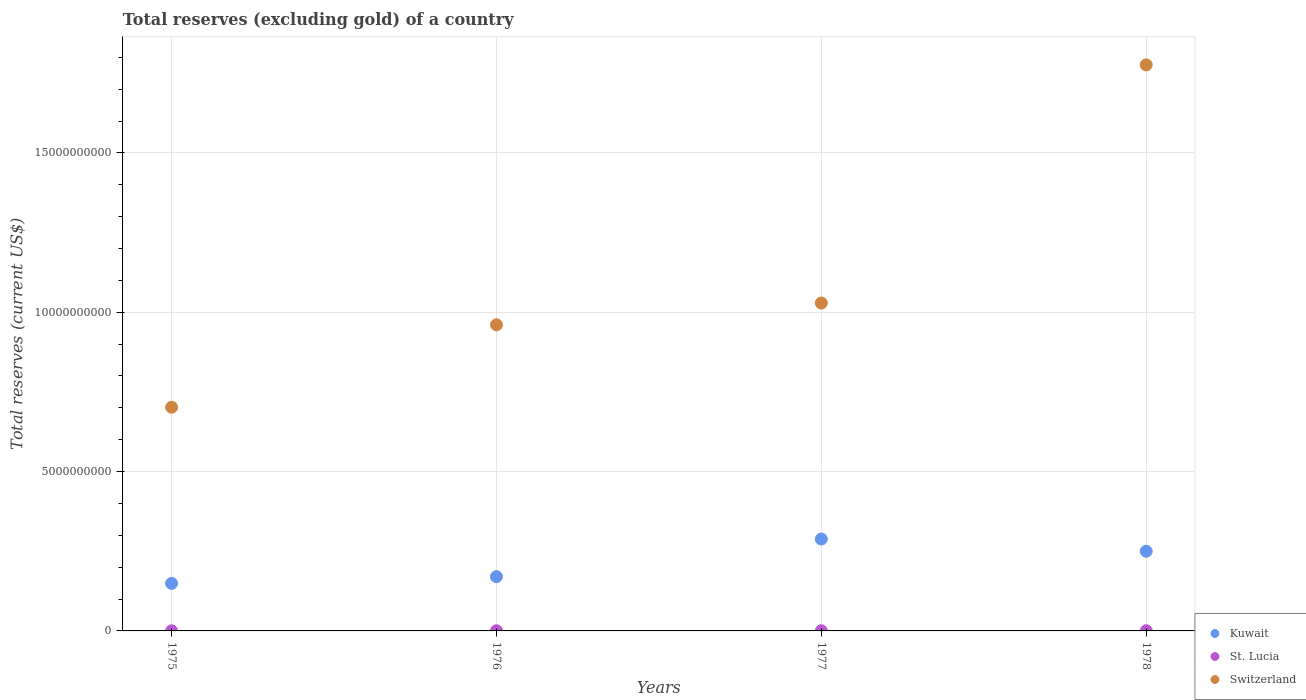Is the number of dotlines equal to the number of legend labels?
Ensure brevity in your answer.  Yes. What is the total reserves (excluding gold) in Switzerland in 1977?
Offer a terse response. 1.03e+1. Across all years, what is the maximum total reserves (excluding gold) in St. Lucia?
Your response must be concise. 6.76e+06. Across all years, what is the minimum total reserves (excluding gold) in Switzerland?
Give a very brief answer. 7.02e+09. In which year was the total reserves (excluding gold) in St. Lucia maximum?
Provide a succinct answer. 1978. In which year was the total reserves (excluding gold) in Switzerland minimum?
Your response must be concise. 1975. What is the total total reserves (excluding gold) in Switzerland in the graph?
Your answer should be compact. 4.47e+1. What is the difference between the total reserves (excluding gold) in Switzerland in 1976 and that in 1978?
Your answer should be compact. -8.16e+09. What is the difference between the total reserves (excluding gold) in St. Lucia in 1978 and the total reserves (excluding gold) in Kuwait in 1977?
Offer a terse response. -2.88e+09. What is the average total reserves (excluding gold) in St. Lucia per year?
Your answer should be very brief. 5.21e+06. In the year 1975, what is the difference between the total reserves (excluding gold) in St. Lucia and total reserves (excluding gold) in Kuwait?
Offer a terse response. -1.49e+09. What is the ratio of the total reserves (excluding gold) in St. Lucia in 1975 to that in 1976?
Provide a short and direct response. 0.62. Is the total reserves (excluding gold) in Kuwait in 1975 less than that in 1976?
Ensure brevity in your answer.  Yes. What is the difference between the highest and the second highest total reserves (excluding gold) in Switzerland?
Give a very brief answer. 7.47e+09. What is the difference between the highest and the lowest total reserves (excluding gold) in Kuwait?
Ensure brevity in your answer.  1.39e+09. Is the sum of the total reserves (excluding gold) in St. Lucia in 1976 and 1977 greater than the maximum total reserves (excluding gold) in Kuwait across all years?
Provide a succinct answer. No. Does the total reserves (excluding gold) in St. Lucia monotonically increase over the years?
Your answer should be compact. Yes. Is the total reserves (excluding gold) in St. Lucia strictly greater than the total reserves (excluding gold) in Kuwait over the years?
Ensure brevity in your answer.  No. Is the total reserves (excluding gold) in Kuwait strictly less than the total reserves (excluding gold) in St. Lucia over the years?
Keep it short and to the point. No. Does the graph contain any zero values?
Your answer should be compact. No. Does the graph contain grids?
Make the answer very short. Yes. Where does the legend appear in the graph?
Your answer should be very brief. Bottom right. How many legend labels are there?
Your answer should be compact. 3. How are the legend labels stacked?
Ensure brevity in your answer.  Vertical. What is the title of the graph?
Ensure brevity in your answer.  Total reserves (excluding gold) of a country. Does "Hong Kong" appear as one of the legend labels in the graph?
Ensure brevity in your answer.  No. What is the label or title of the X-axis?
Offer a very short reply. Years. What is the label or title of the Y-axis?
Provide a succinct answer. Total reserves (current US$). What is the Total reserves (current US$) of Kuwait in 1975?
Keep it short and to the point. 1.49e+09. What is the Total reserves (current US$) of St. Lucia in 1975?
Offer a terse response. 3.24e+06. What is the Total reserves (current US$) of Switzerland in 1975?
Provide a succinct answer. 7.02e+09. What is the Total reserves (current US$) in Kuwait in 1976?
Ensure brevity in your answer.  1.70e+09. What is the Total reserves (current US$) in St. Lucia in 1976?
Offer a very short reply. 5.19e+06. What is the Total reserves (current US$) in Switzerland in 1976?
Offer a terse response. 9.61e+09. What is the Total reserves (current US$) of Kuwait in 1977?
Keep it short and to the point. 2.88e+09. What is the Total reserves (current US$) of St. Lucia in 1977?
Ensure brevity in your answer.  5.65e+06. What is the Total reserves (current US$) of Switzerland in 1977?
Offer a very short reply. 1.03e+1. What is the Total reserves (current US$) of Kuwait in 1978?
Your response must be concise. 2.50e+09. What is the Total reserves (current US$) in St. Lucia in 1978?
Your response must be concise. 6.76e+06. What is the Total reserves (current US$) in Switzerland in 1978?
Offer a very short reply. 1.78e+1. Across all years, what is the maximum Total reserves (current US$) of Kuwait?
Make the answer very short. 2.88e+09. Across all years, what is the maximum Total reserves (current US$) in St. Lucia?
Your response must be concise. 6.76e+06. Across all years, what is the maximum Total reserves (current US$) of Switzerland?
Provide a succinct answer. 1.78e+1. Across all years, what is the minimum Total reserves (current US$) of Kuwait?
Provide a short and direct response. 1.49e+09. Across all years, what is the minimum Total reserves (current US$) of St. Lucia?
Make the answer very short. 3.24e+06. Across all years, what is the minimum Total reserves (current US$) of Switzerland?
Ensure brevity in your answer.  7.02e+09. What is the total Total reserves (current US$) of Kuwait in the graph?
Your answer should be compact. 8.58e+09. What is the total Total reserves (current US$) in St. Lucia in the graph?
Your answer should be very brief. 2.08e+07. What is the total Total reserves (current US$) of Switzerland in the graph?
Your answer should be compact. 4.47e+1. What is the difference between the Total reserves (current US$) of Kuwait in 1975 and that in 1976?
Keep it short and to the point. -2.10e+08. What is the difference between the Total reserves (current US$) of St. Lucia in 1975 and that in 1976?
Make the answer very short. -1.95e+06. What is the difference between the Total reserves (current US$) of Switzerland in 1975 and that in 1976?
Your response must be concise. -2.59e+09. What is the difference between the Total reserves (current US$) of Kuwait in 1975 and that in 1977?
Your answer should be very brief. -1.39e+09. What is the difference between the Total reserves (current US$) in St. Lucia in 1975 and that in 1977?
Offer a very short reply. -2.41e+06. What is the difference between the Total reserves (current US$) in Switzerland in 1975 and that in 1977?
Give a very brief answer. -3.27e+09. What is the difference between the Total reserves (current US$) in Kuwait in 1975 and that in 1978?
Make the answer very short. -1.01e+09. What is the difference between the Total reserves (current US$) in St. Lucia in 1975 and that in 1978?
Offer a very short reply. -3.52e+06. What is the difference between the Total reserves (current US$) in Switzerland in 1975 and that in 1978?
Offer a terse response. -1.07e+1. What is the difference between the Total reserves (current US$) in Kuwait in 1976 and that in 1977?
Your answer should be very brief. -1.18e+09. What is the difference between the Total reserves (current US$) of St. Lucia in 1976 and that in 1977?
Offer a terse response. -4.61e+05. What is the difference between the Total reserves (current US$) of Switzerland in 1976 and that in 1977?
Provide a succinct answer. -6.83e+08. What is the difference between the Total reserves (current US$) in Kuwait in 1976 and that in 1978?
Offer a very short reply. -7.99e+08. What is the difference between the Total reserves (current US$) in St. Lucia in 1976 and that in 1978?
Keep it short and to the point. -1.57e+06. What is the difference between the Total reserves (current US$) in Switzerland in 1976 and that in 1978?
Ensure brevity in your answer.  -8.16e+09. What is the difference between the Total reserves (current US$) in Kuwait in 1977 and that in 1978?
Make the answer very short. 3.83e+08. What is the difference between the Total reserves (current US$) of St. Lucia in 1977 and that in 1978?
Keep it short and to the point. -1.10e+06. What is the difference between the Total reserves (current US$) of Switzerland in 1977 and that in 1978?
Make the answer very short. -7.47e+09. What is the difference between the Total reserves (current US$) in Kuwait in 1975 and the Total reserves (current US$) in St. Lucia in 1976?
Provide a succinct answer. 1.49e+09. What is the difference between the Total reserves (current US$) in Kuwait in 1975 and the Total reserves (current US$) in Switzerland in 1976?
Your answer should be compact. -8.11e+09. What is the difference between the Total reserves (current US$) in St. Lucia in 1975 and the Total reserves (current US$) in Switzerland in 1976?
Provide a short and direct response. -9.60e+09. What is the difference between the Total reserves (current US$) in Kuwait in 1975 and the Total reserves (current US$) in St. Lucia in 1977?
Your answer should be very brief. 1.49e+09. What is the difference between the Total reserves (current US$) of Kuwait in 1975 and the Total reserves (current US$) of Switzerland in 1977?
Provide a succinct answer. -8.80e+09. What is the difference between the Total reserves (current US$) of St. Lucia in 1975 and the Total reserves (current US$) of Switzerland in 1977?
Offer a terse response. -1.03e+1. What is the difference between the Total reserves (current US$) in Kuwait in 1975 and the Total reserves (current US$) in St. Lucia in 1978?
Ensure brevity in your answer.  1.48e+09. What is the difference between the Total reserves (current US$) in Kuwait in 1975 and the Total reserves (current US$) in Switzerland in 1978?
Your answer should be compact. -1.63e+1. What is the difference between the Total reserves (current US$) in St. Lucia in 1975 and the Total reserves (current US$) in Switzerland in 1978?
Offer a very short reply. -1.78e+1. What is the difference between the Total reserves (current US$) of Kuwait in 1976 and the Total reserves (current US$) of St. Lucia in 1977?
Ensure brevity in your answer.  1.70e+09. What is the difference between the Total reserves (current US$) in Kuwait in 1976 and the Total reserves (current US$) in Switzerland in 1977?
Make the answer very short. -8.59e+09. What is the difference between the Total reserves (current US$) of St. Lucia in 1976 and the Total reserves (current US$) of Switzerland in 1977?
Your response must be concise. -1.03e+1. What is the difference between the Total reserves (current US$) in Kuwait in 1976 and the Total reserves (current US$) in St. Lucia in 1978?
Offer a very short reply. 1.70e+09. What is the difference between the Total reserves (current US$) in Kuwait in 1976 and the Total reserves (current US$) in Switzerland in 1978?
Provide a succinct answer. -1.61e+1. What is the difference between the Total reserves (current US$) in St. Lucia in 1976 and the Total reserves (current US$) in Switzerland in 1978?
Your answer should be very brief. -1.78e+1. What is the difference between the Total reserves (current US$) of Kuwait in 1977 and the Total reserves (current US$) of St. Lucia in 1978?
Provide a short and direct response. 2.88e+09. What is the difference between the Total reserves (current US$) of Kuwait in 1977 and the Total reserves (current US$) of Switzerland in 1978?
Provide a succinct answer. -1.49e+1. What is the difference between the Total reserves (current US$) of St. Lucia in 1977 and the Total reserves (current US$) of Switzerland in 1978?
Give a very brief answer. -1.78e+1. What is the average Total reserves (current US$) of Kuwait per year?
Keep it short and to the point. 2.14e+09. What is the average Total reserves (current US$) of St. Lucia per year?
Provide a succinct answer. 5.21e+06. What is the average Total reserves (current US$) in Switzerland per year?
Make the answer very short. 1.12e+1. In the year 1975, what is the difference between the Total reserves (current US$) in Kuwait and Total reserves (current US$) in St. Lucia?
Keep it short and to the point. 1.49e+09. In the year 1975, what is the difference between the Total reserves (current US$) in Kuwait and Total reserves (current US$) in Switzerland?
Keep it short and to the point. -5.53e+09. In the year 1975, what is the difference between the Total reserves (current US$) in St. Lucia and Total reserves (current US$) in Switzerland?
Offer a terse response. -7.02e+09. In the year 1976, what is the difference between the Total reserves (current US$) of Kuwait and Total reserves (current US$) of St. Lucia?
Ensure brevity in your answer.  1.70e+09. In the year 1976, what is the difference between the Total reserves (current US$) in Kuwait and Total reserves (current US$) in Switzerland?
Your answer should be compact. -7.90e+09. In the year 1976, what is the difference between the Total reserves (current US$) in St. Lucia and Total reserves (current US$) in Switzerland?
Your response must be concise. -9.60e+09. In the year 1977, what is the difference between the Total reserves (current US$) of Kuwait and Total reserves (current US$) of St. Lucia?
Keep it short and to the point. 2.88e+09. In the year 1977, what is the difference between the Total reserves (current US$) in Kuwait and Total reserves (current US$) in Switzerland?
Give a very brief answer. -7.41e+09. In the year 1977, what is the difference between the Total reserves (current US$) in St. Lucia and Total reserves (current US$) in Switzerland?
Provide a short and direct response. -1.03e+1. In the year 1978, what is the difference between the Total reserves (current US$) of Kuwait and Total reserves (current US$) of St. Lucia?
Ensure brevity in your answer.  2.49e+09. In the year 1978, what is the difference between the Total reserves (current US$) of Kuwait and Total reserves (current US$) of Switzerland?
Offer a terse response. -1.53e+1. In the year 1978, what is the difference between the Total reserves (current US$) of St. Lucia and Total reserves (current US$) of Switzerland?
Provide a short and direct response. -1.78e+1. What is the ratio of the Total reserves (current US$) in Kuwait in 1975 to that in 1976?
Your answer should be compact. 0.88. What is the ratio of the Total reserves (current US$) of St. Lucia in 1975 to that in 1976?
Ensure brevity in your answer.  0.62. What is the ratio of the Total reserves (current US$) in Switzerland in 1975 to that in 1976?
Ensure brevity in your answer.  0.73. What is the ratio of the Total reserves (current US$) of Kuwait in 1975 to that in 1977?
Ensure brevity in your answer.  0.52. What is the ratio of the Total reserves (current US$) in St. Lucia in 1975 to that in 1977?
Ensure brevity in your answer.  0.57. What is the ratio of the Total reserves (current US$) of Switzerland in 1975 to that in 1977?
Provide a short and direct response. 0.68. What is the ratio of the Total reserves (current US$) in Kuwait in 1975 to that in 1978?
Your response must be concise. 0.6. What is the ratio of the Total reserves (current US$) of St. Lucia in 1975 to that in 1978?
Offer a very short reply. 0.48. What is the ratio of the Total reserves (current US$) in Switzerland in 1975 to that in 1978?
Your answer should be very brief. 0.4. What is the ratio of the Total reserves (current US$) of Kuwait in 1976 to that in 1977?
Offer a terse response. 0.59. What is the ratio of the Total reserves (current US$) in St. Lucia in 1976 to that in 1977?
Keep it short and to the point. 0.92. What is the ratio of the Total reserves (current US$) in Switzerland in 1976 to that in 1977?
Give a very brief answer. 0.93. What is the ratio of the Total reserves (current US$) of Kuwait in 1976 to that in 1978?
Keep it short and to the point. 0.68. What is the ratio of the Total reserves (current US$) in St. Lucia in 1976 to that in 1978?
Provide a short and direct response. 0.77. What is the ratio of the Total reserves (current US$) of Switzerland in 1976 to that in 1978?
Make the answer very short. 0.54. What is the ratio of the Total reserves (current US$) of Kuwait in 1977 to that in 1978?
Give a very brief answer. 1.15. What is the ratio of the Total reserves (current US$) in St. Lucia in 1977 to that in 1978?
Offer a terse response. 0.84. What is the ratio of the Total reserves (current US$) of Switzerland in 1977 to that in 1978?
Offer a very short reply. 0.58. What is the difference between the highest and the second highest Total reserves (current US$) in Kuwait?
Your answer should be very brief. 3.83e+08. What is the difference between the highest and the second highest Total reserves (current US$) of St. Lucia?
Provide a short and direct response. 1.10e+06. What is the difference between the highest and the second highest Total reserves (current US$) of Switzerland?
Provide a succinct answer. 7.47e+09. What is the difference between the highest and the lowest Total reserves (current US$) of Kuwait?
Keep it short and to the point. 1.39e+09. What is the difference between the highest and the lowest Total reserves (current US$) of St. Lucia?
Offer a very short reply. 3.52e+06. What is the difference between the highest and the lowest Total reserves (current US$) in Switzerland?
Offer a very short reply. 1.07e+1. 